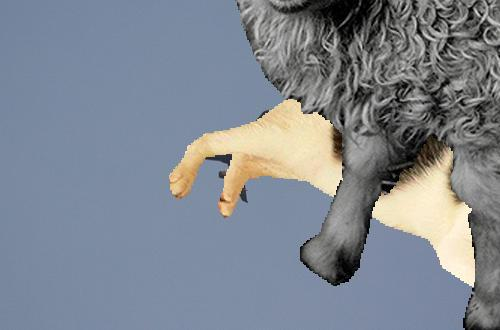How many unicorns are there in the image? The image does not contain any unicorns. It features a creatively edited sheep where its hooves are artistically manipulated to look like human hands. 